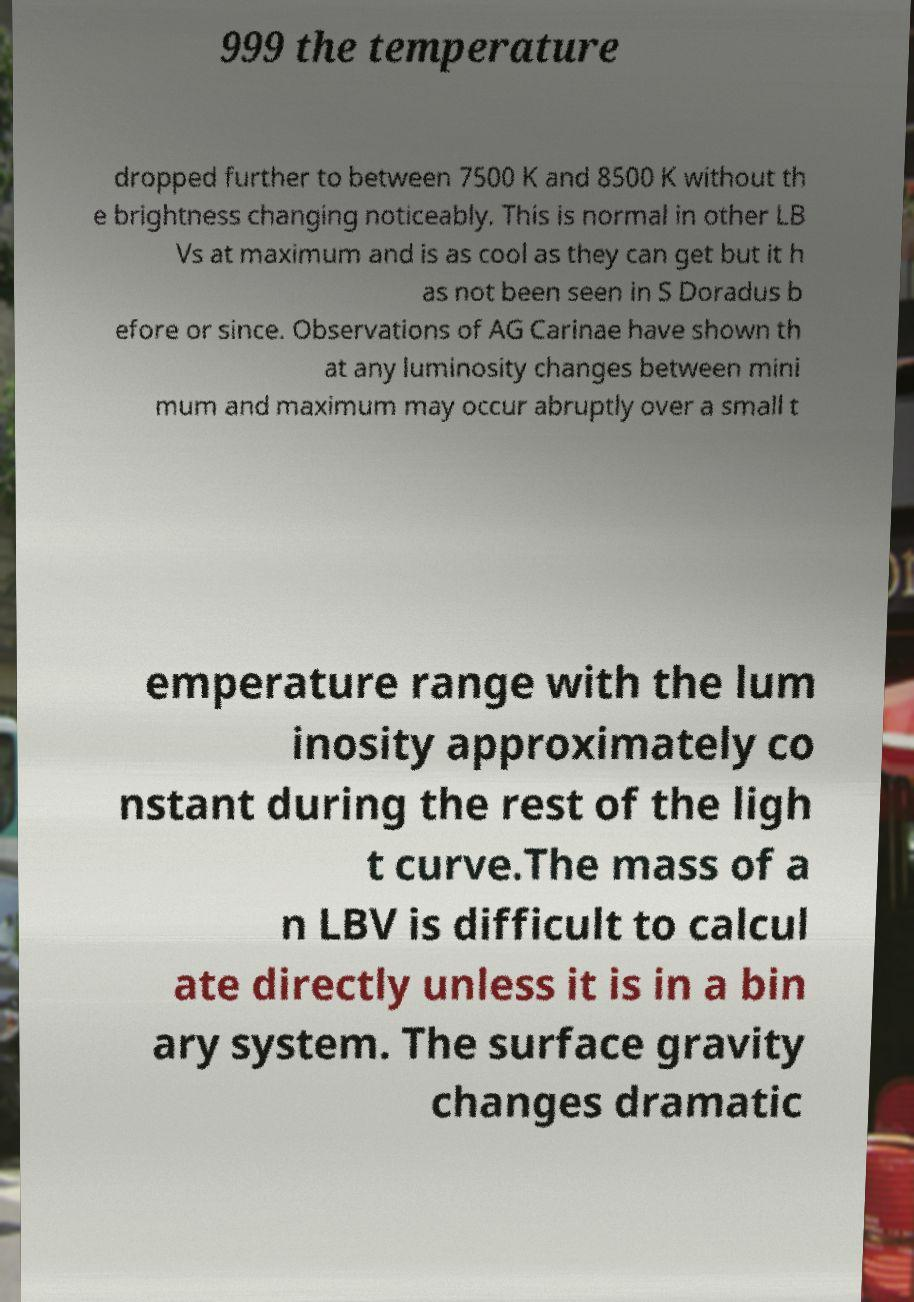Could you assist in decoding the text presented in this image and type it out clearly? 999 the temperature dropped further to between 7500 K and 8500 K without th e brightness changing noticeably. This is normal in other LB Vs at maximum and is as cool as they can get but it h as not been seen in S Doradus b efore or since. Observations of AG Carinae have shown th at any luminosity changes between mini mum and maximum may occur abruptly over a small t emperature range with the lum inosity approximately co nstant during the rest of the ligh t curve.The mass of a n LBV is difficult to calcul ate directly unless it is in a bin ary system. The surface gravity changes dramatic 